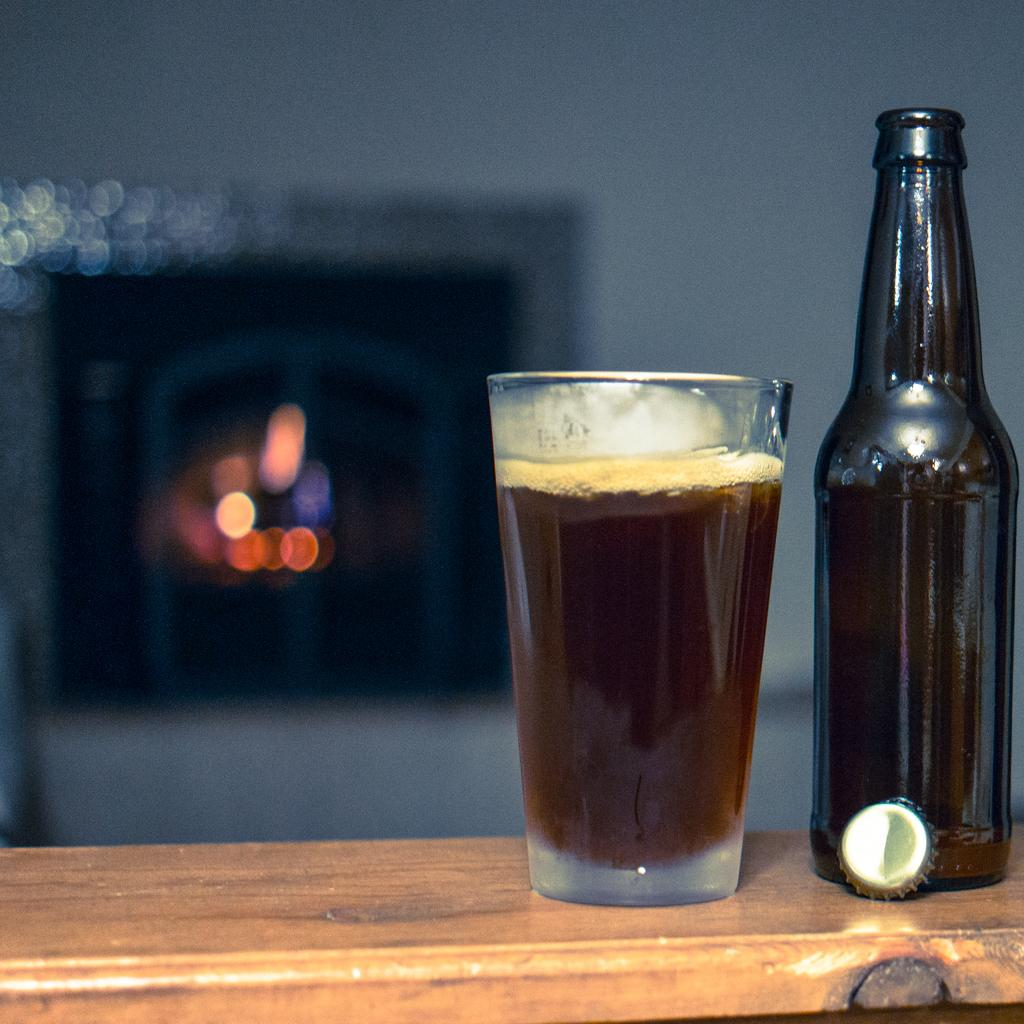What is on the table in the image? There is a bottle and a glass on the table. What is in the glass? The glass contains a brown color liquid. What can be seen in the background of the image? There is a wall visible in the background. What architectural feature is present in the wall? There is a window in the wall. What theory is being discussed by the cats in the image? There are no cats present in the image, so there is no discussion or theory to be considered. 